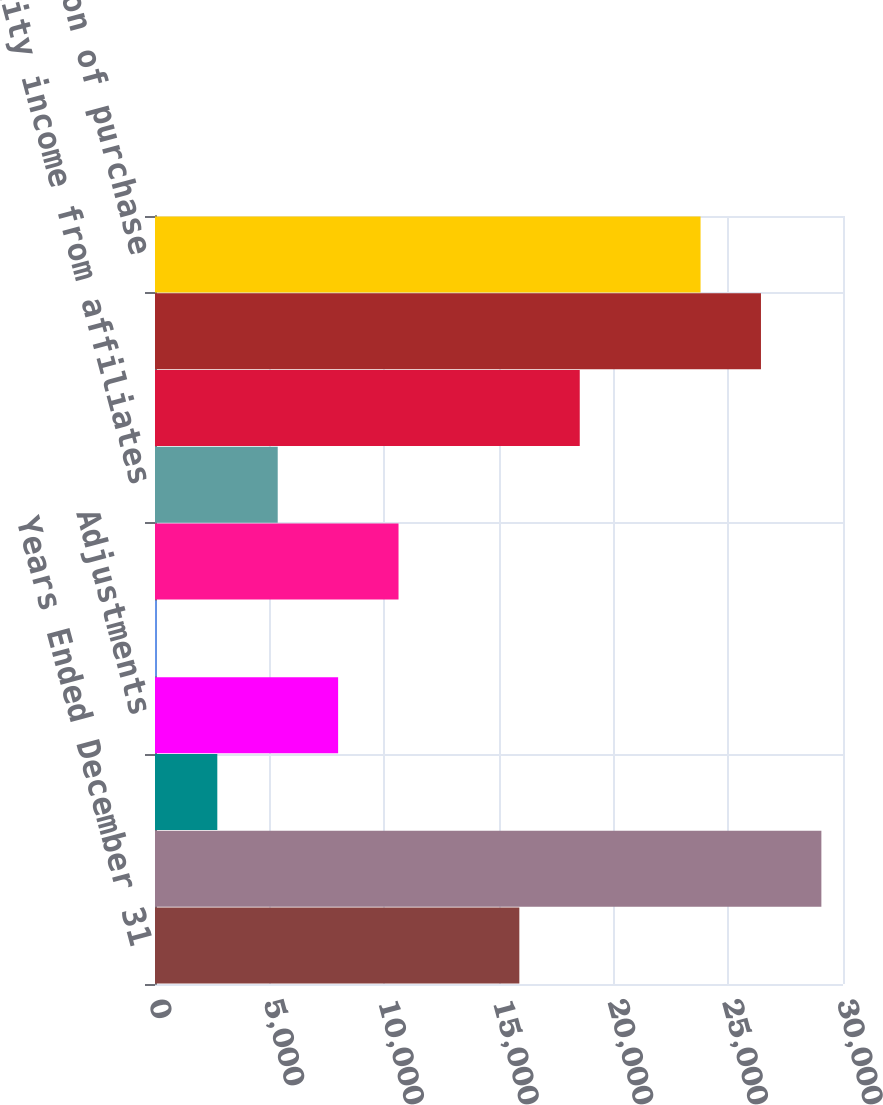Convert chart. <chart><loc_0><loc_0><loc_500><loc_500><bar_chart><fcel>Years Ended December 31<fcel>Segment profits<fcel>Other profits (losses)<fcel>Adjustments<fcel>Interest income<fcel>Interest expense<fcel>Equity income from affiliates<fcel>Depreciation and amortization<fcel>Research and development<fcel>Amortization of purchase<nl><fcel>15887<fcel>29057<fcel>2717<fcel>7985<fcel>83<fcel>10619<fcel>5351<fcel>18521<fcel>26423<fcel>23789<nl></chart> 